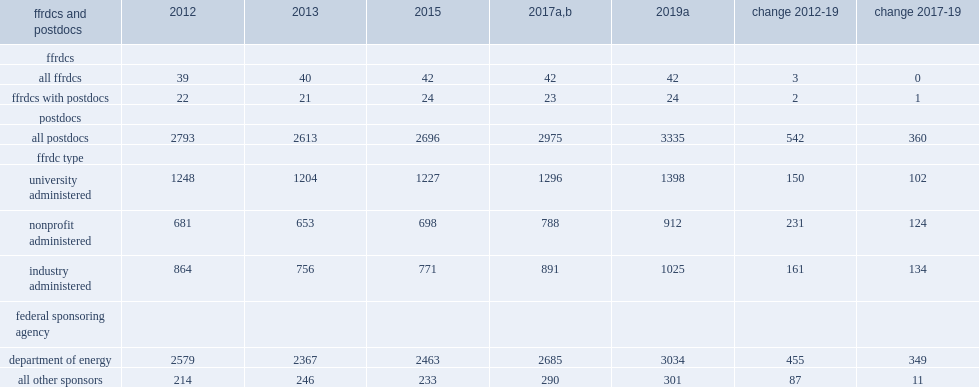How many postdocs were employed at ffrdcs in 2019? 3335.0. 